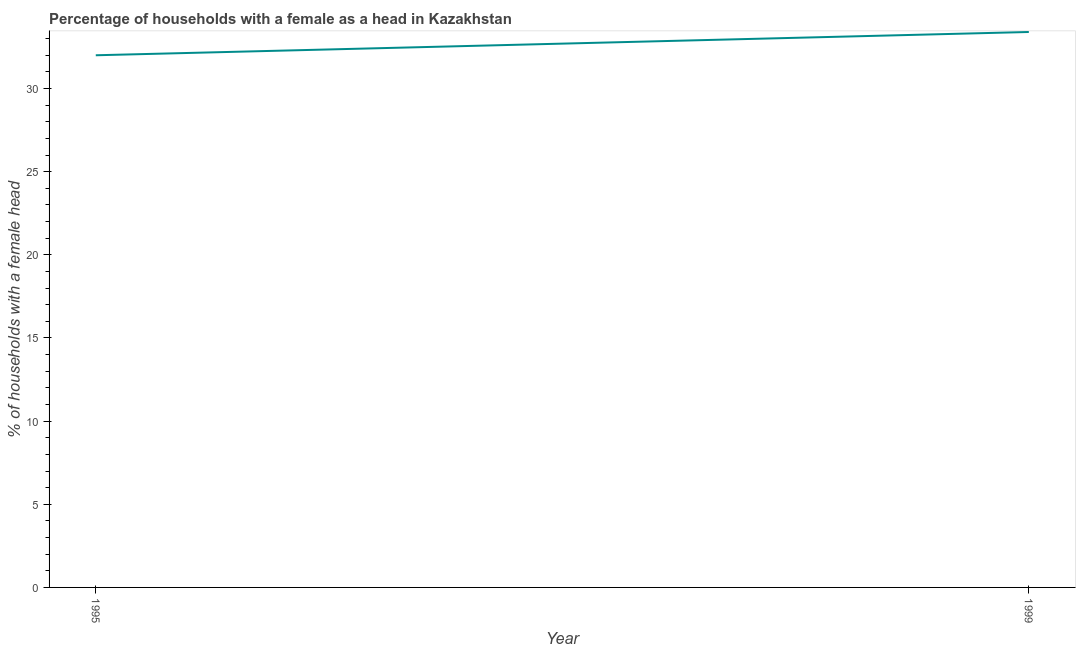Across all years, what is the maximum number of female supervised households?
Make the answer very short. 33.4. Across all years, what is the minimum number of female supervised households?
Provide a short and direct response. 32. In which year was the number of female supervised households minimum?
Your answer should be compact. 1995. What is the sum of the number of female supervised households?
Your answer should be compact. 65.4. What is the difference between the number of female supervised households in 1995 and 1999?
Keep it short and to the point. -1.4. What is the average number of female supervised households per year?
Give a very brief answer. 32.7. What is the median number of female supervised households?
Ensure brevity in your answer.  32.7. In how many years, is the number of female supervised households greater than 8 %?
Provide a succinct answer. 2. What is the ratio of the number of female supervised households in 1995 to that in 1999?
Provide a short and direct response. 0.96. Is the number of female supervised households in 1995 less than that in 1999?
Your answer should be very brief. Yes. In how many years, is the number of female supervised households greater than the average number of female supervised households taken over all years?
Offer a terse response. 1. Does the number of female supervised households monotonically increase over the years?
Offer a very short reply. Yes. How many lines are there?
Keep it short and to the point. 1. How many years are there in the graph?
Give a very brief answer. 2. Does the graph contain any zero values?
Offer a terse response. No. What is the title of the graph?
Offer a terse response. Percentage of households with a female as a head in Kazakhstan. What is the label or title of the Y-axis?
Your answer should be compact. % of households with a female head. What is the % of households with a female head in 1999?
Offer a terse response. 33.4. What is the ratio of the % of households with a female head in 1995 to that in 1999?
Keep it short and to the point. 0.96. 